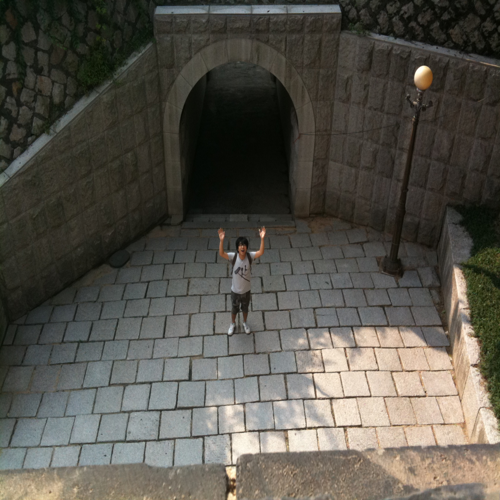Can you suggest some historical contexts that this kind of tunnel might be associated with? While this is a contemporary image, tunnels of this nature have been around for centuries and can be associated with historic fortifications, city defenses, or as part of an old castle's infrastructure. 